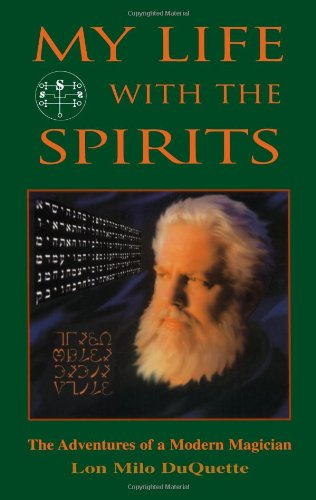What is the genre of this book? This book belongs to the 'Biographies & Memoirs' genre, specifically focusing on the autobiographical accounts of a modern magician's experiences with the occult. 